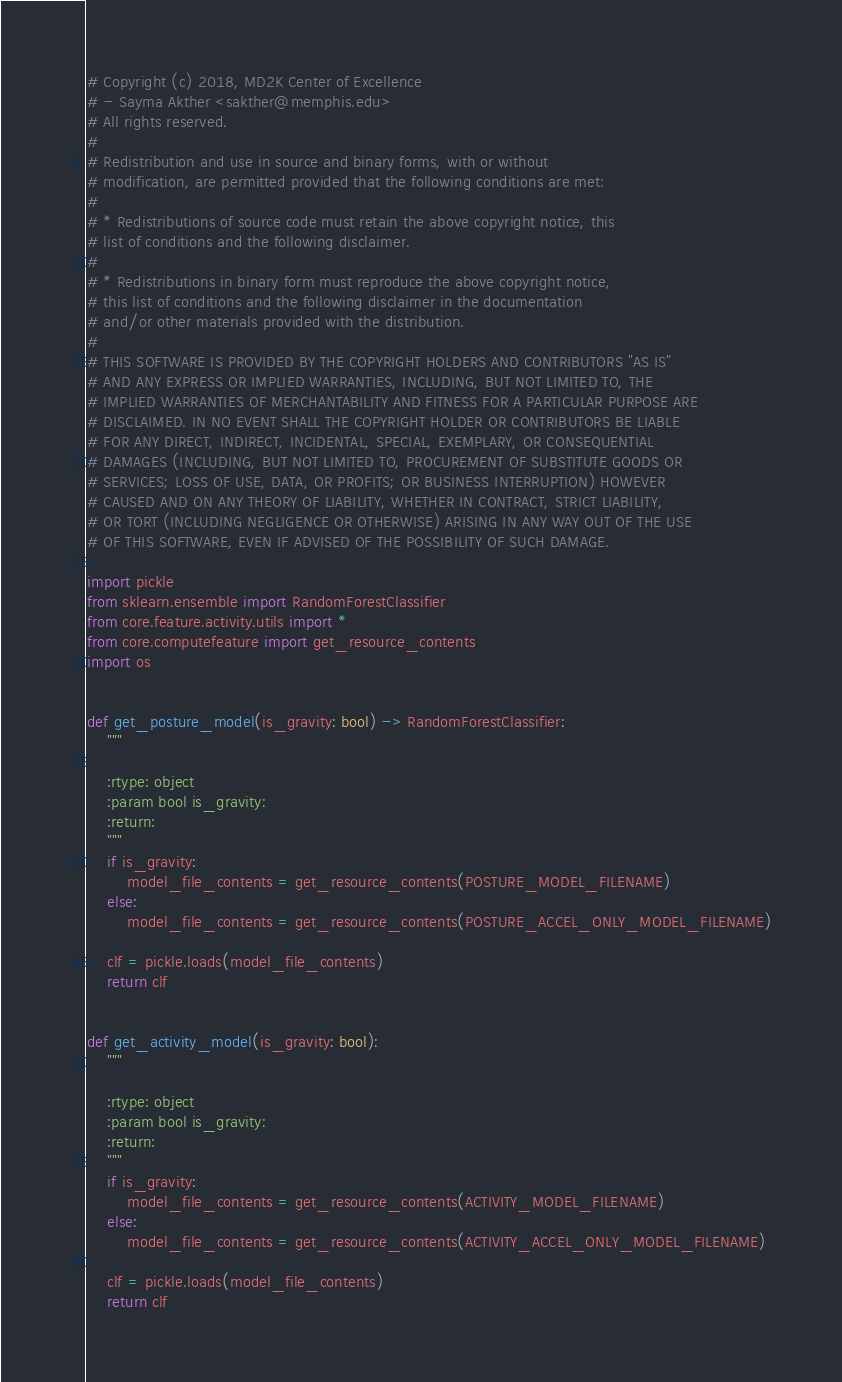Convert code to text. <code><loc_0><loc_0><loc_500><loc_500><_Python_># Copyright (c) 2018, MD2K Center of Excellence
# - Sayma Akther <sakther@memphis.edu>
# All rights reserved.
#
# Redistribution and use in source and binary forms, with or without
# modification, are permitted provided that the following conditions are met:
#
# * Redistributions of source code must retain the above copyright notice, this
# list of conditions and the following disclaimer.
#
# * Redistributions in binary form must reproduce the above copyright notice,
# this list of conditions and the following disclaimer in the documentation
# and/or other materials provided with the distribution.
#
# THIS SOFTWARE IS PROVIDED BY THE COPYRIGHT HOLDERS AND CONTRIBUTORS "AS IS"
# AND ANY EXPRESS OR IMPLIED WARRANTIES, INCLUDING, BUT NOT LIMITED TO, THE
# IMPLIED WARRANTIES OF MERCHANTABILITY AND FITNESS FOR A PARTICULAR PURPOSE ARE
# DISCLAIMED. IN NO EVENT SHALL THE COPYRIGHT HOLDER OR CONTRIBUTORS BE LIABLE
# FOR ANY DIRECT, INDIRECT, INCIDENTAL, SPECIAL, EXEMPLARY, OR CONSEQUENTIAL
# DAMAGES (INCLUDING, BUT NOT LIMITED TO, PROCUREMENT OF SUBSTITUTE GOODS OR
# SERVICES; LOSS OF USE, DATA, OR PROFITS; OR BUSINESS INTERRUPTION) HOWEVER
# CAUSED AND ON ANY THEORY OF LIABILITY, WHETHER IN CONTRACT, STRICT LIABILITY,
# OR TORT (INCLUDING NEGLIGENCE OR OTHERWISE) ARISING IN ANY WAY OUT OF THE USE
# OF THIS SOFTWARE, EVEN IF ADVISED OF THE POSSIBILITY OF SUCH DAMAGE.

import pickle
from sklearn.ensemble import RandomForestClassifier
from core.feature.activity.utils import *
from core.computefeature import get_resource_contents
import os


def get_posture_model(is_gravity: bool) -> RandomForestClassifier:
    """

    :rtype: object
    :param bool is_gravity:
    :return:
    """
    if is_gravity:
        model_file_contents = get_resource_contents(POSTURE_MODEL_FILENAME)
    else:
        model_file_contents = get_resource_contents(POSTURE_ACCEL_ONLY_MODEL_FILENAME)

    clf = pickle.loads(model_file_contents)
    return clf


def get_activity_model(is_gravity: bool):
    """

    :rtype: object
    :param bool is_gravity:
    :return:
    """
    if is_gravity:
        model_file_contents = get_resource_contents(ACTIVITY_MODEL_FILENAME)
    else:
        model_file_contents = get_resource_contents(ACTIVITY_ACCEL_ONLY_MODEL_FILENAME)

    clf = pickle.loads(model_file_contents)
    return clf
</code> 